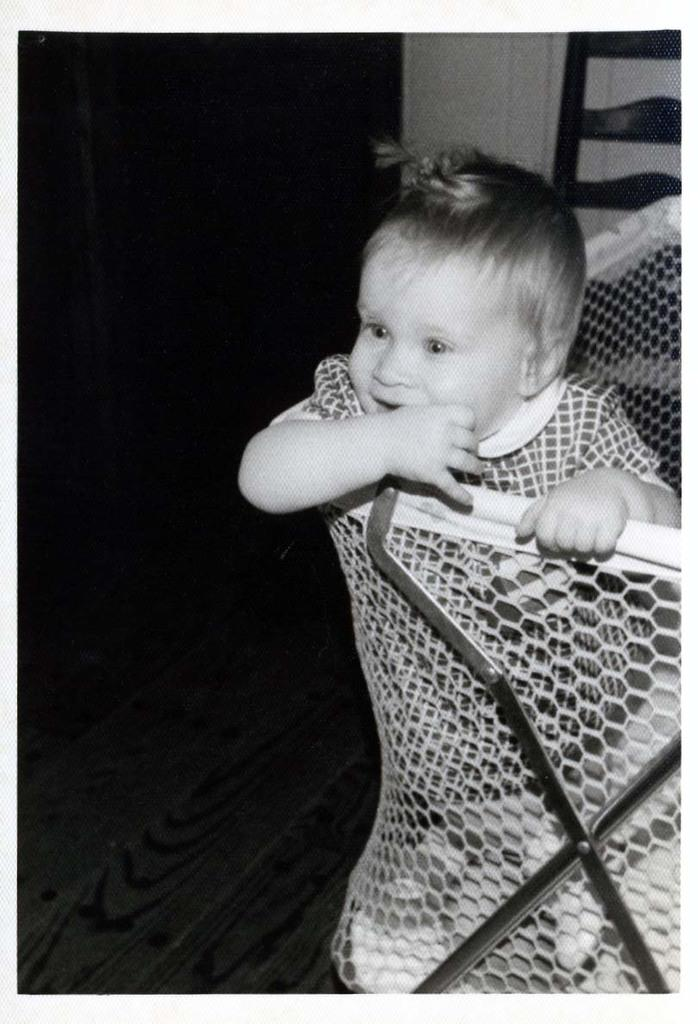What is the main subject of the black and white picture in the image? There is a black and white picture of a baby in a basket in the image. How is the basket positioned in the image? The basket is placed on stands. What can be seen in the background of the image? There is a chair and a wall in the background of the image. What type of word is being used to describe the baby's oatmeal in the image? There is no mention of oatmeal or any word being used to describe it in the image. How many feet can be seen in the image? There are no feet visible in the image; it features a picture of a baby in a basket. 